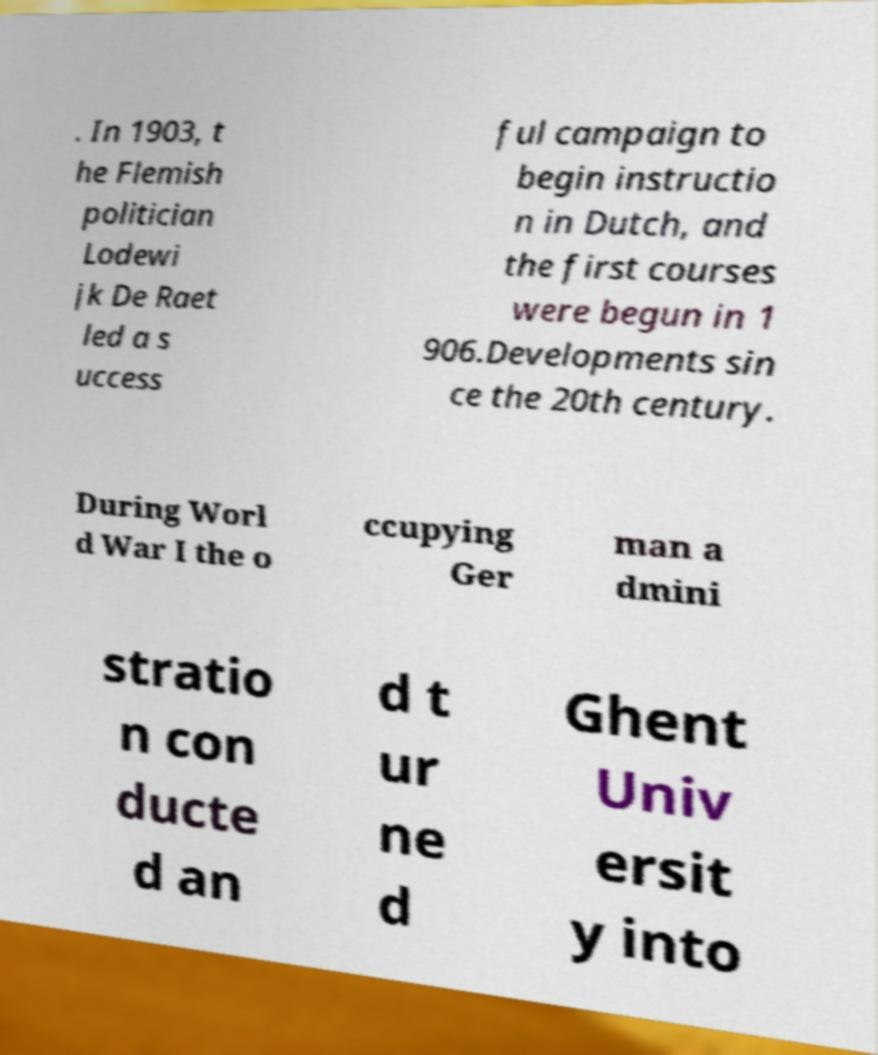Please identify and transcribe the text found in this image. . In 1903, t he Flemish politician Lodewi jk De Raet led a s uccess ful campaign to begin instructio n in Dutch, and the first courses were begun in 1 906.Developments sin ce the 20th century. During Worl d War I the o ccupying Ger man a dmini stratio n con ducte d an d t ur ne d Ghent Univ ersit y into 